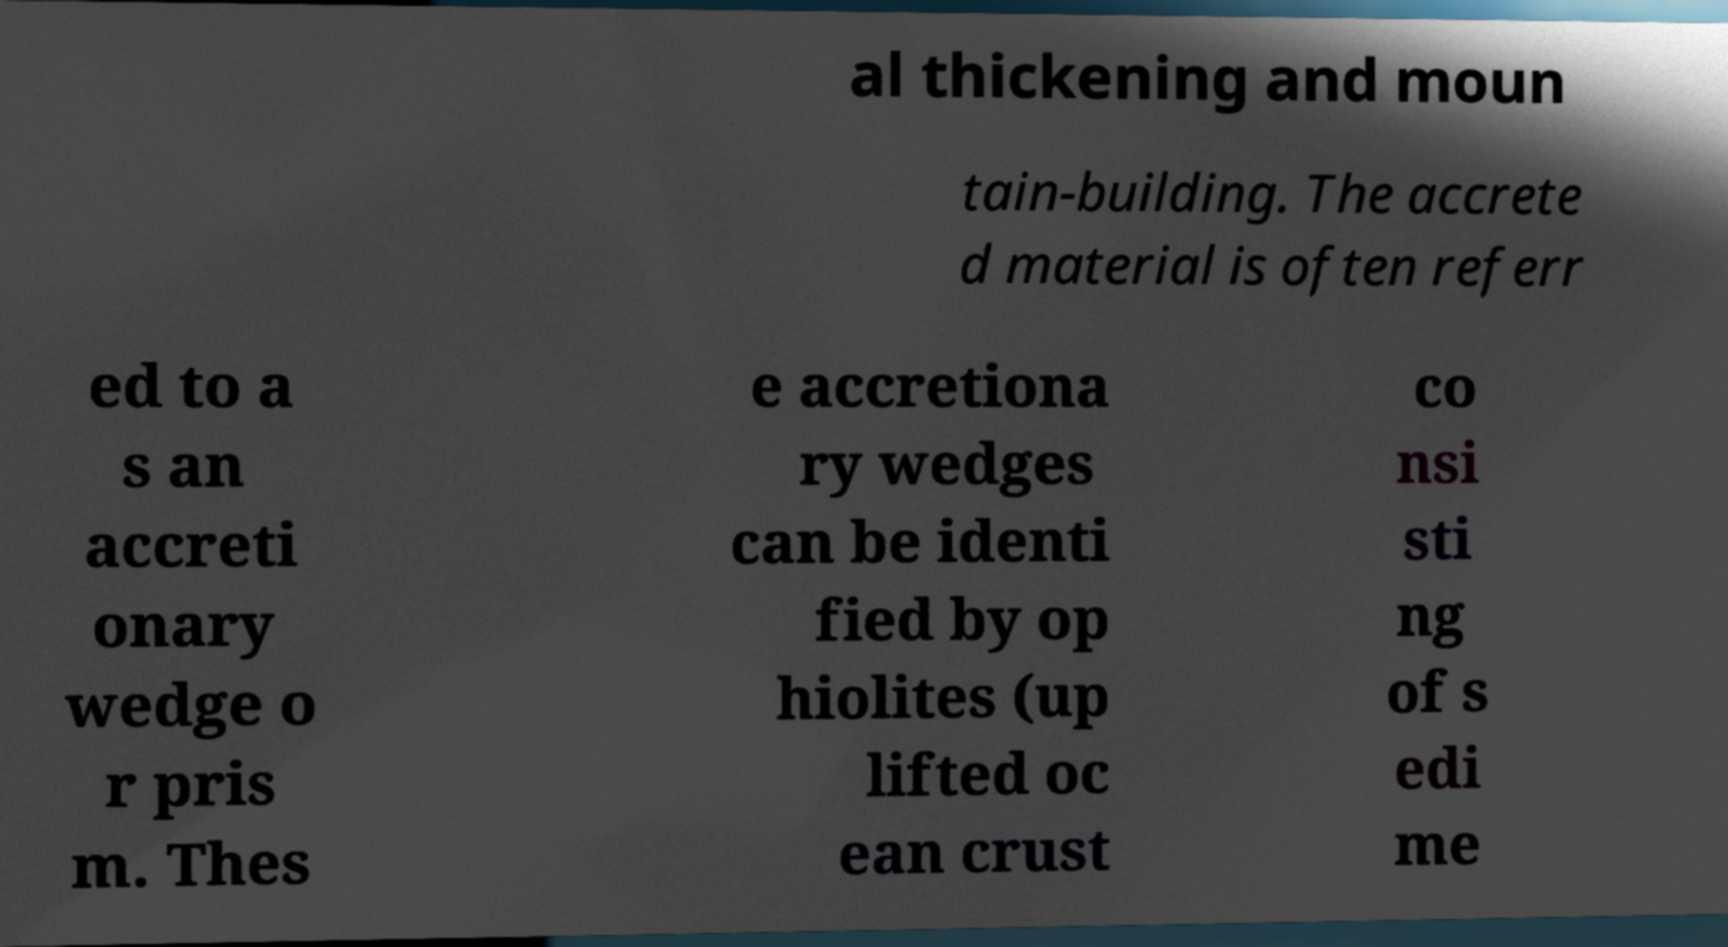I need the written content from this picture converted into text. Can you do that? al thickening and moun tain-building. The accrete d material is often referr ed to a s an accreti onary wedge o r pris m. Thes e accretiona ry wedges can be identi fied by op hiolites (up lifted oc ean crust co nsi sti ng of s edi me 